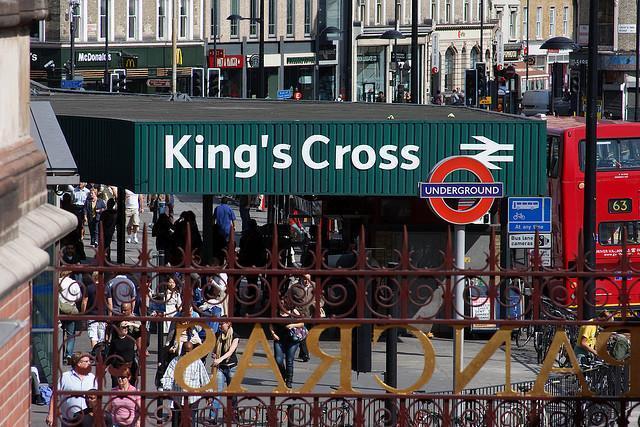How many people are visible?
Give a very brief answer. 2. 